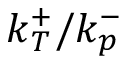<formula> <loc_0><loc_0><loc_500><loc_500>k _ { T } ^ { + } / k _ { p } ^ { - }</formula> 